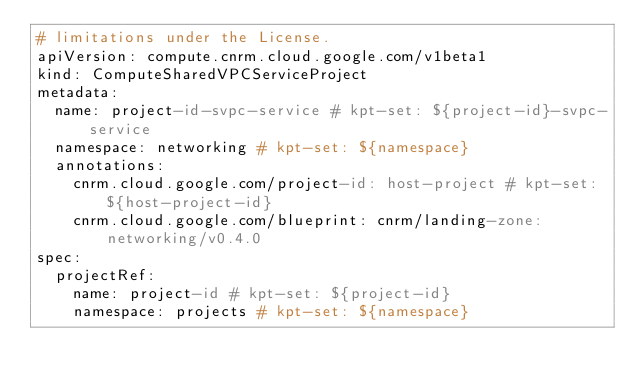<code> <loc_0><loc_0><loc_500><loc_500><_YAML_># limitations under the License.
apiVersion: compute.cnrm.cloud.google.com/v1beta1
kind: ComputeSharedVPCServiceProject
metadata:
  name: project-id-svpc-service # kpt-set: ${project-id}-svpc-service
  namespace: networking # kpt-set: ${namespace}
  annotations:
    cnrm.cloud.google.com/project-id: host-project # kpt-set: ${host-project-id}
    cnrm.cloud.google.com/blueprint: cnrm/landing-zone:networking/v0.4.0
spec:
  projectRef:
    name: project-id # kpt-set: ${project-id}
    namespace: projects # kpt-set: ${namespace}
</code> 